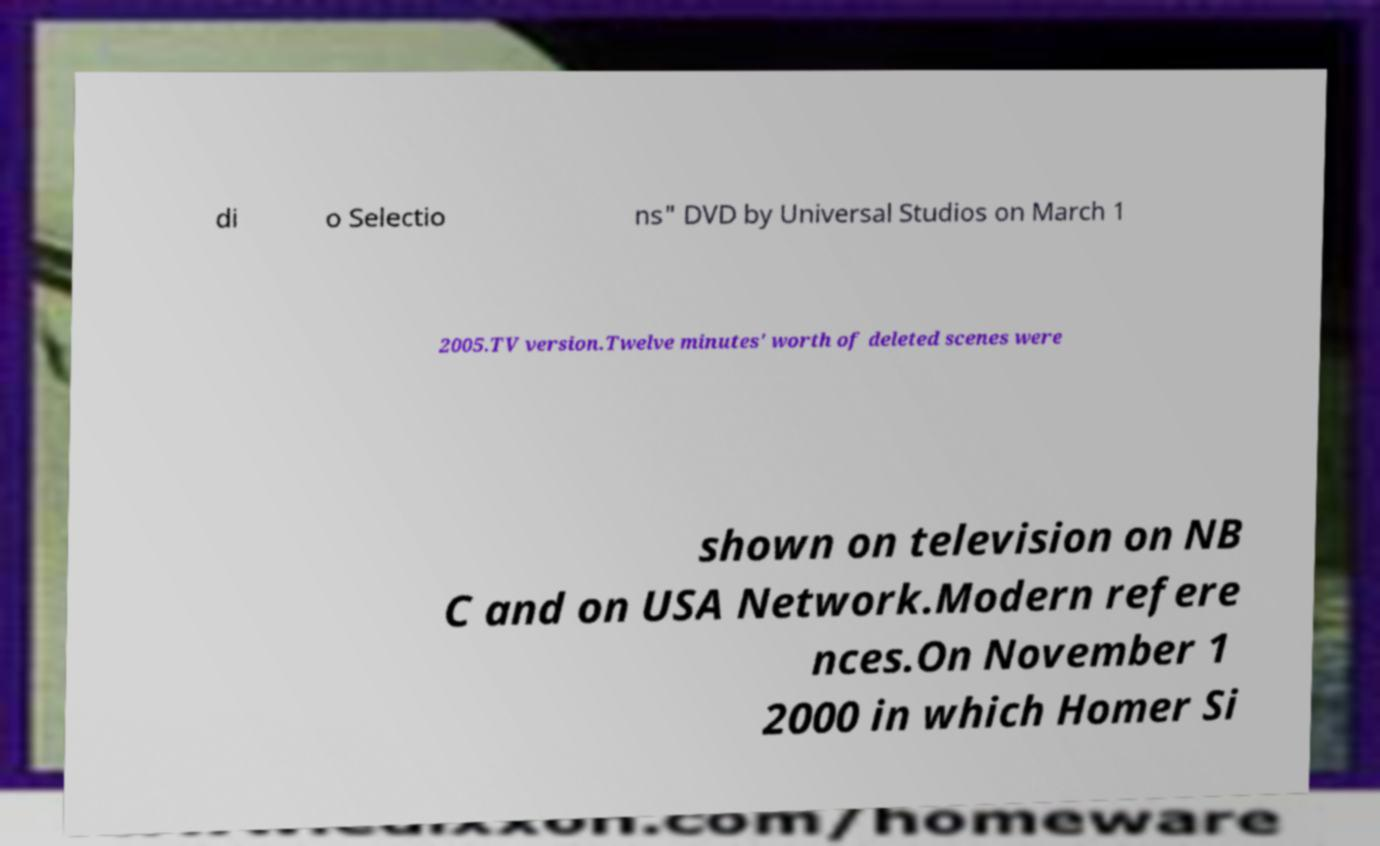Can you accurately transcribe the text from the provided image for me? di o Selectio ns" DVD by Universal Studios on March 1 2005.TV version.Twelve minutes' worth of deleted scenes were shown on television on NB C and on USA Network.Modern refere nces.On November 1 2000 in which Homer Si 